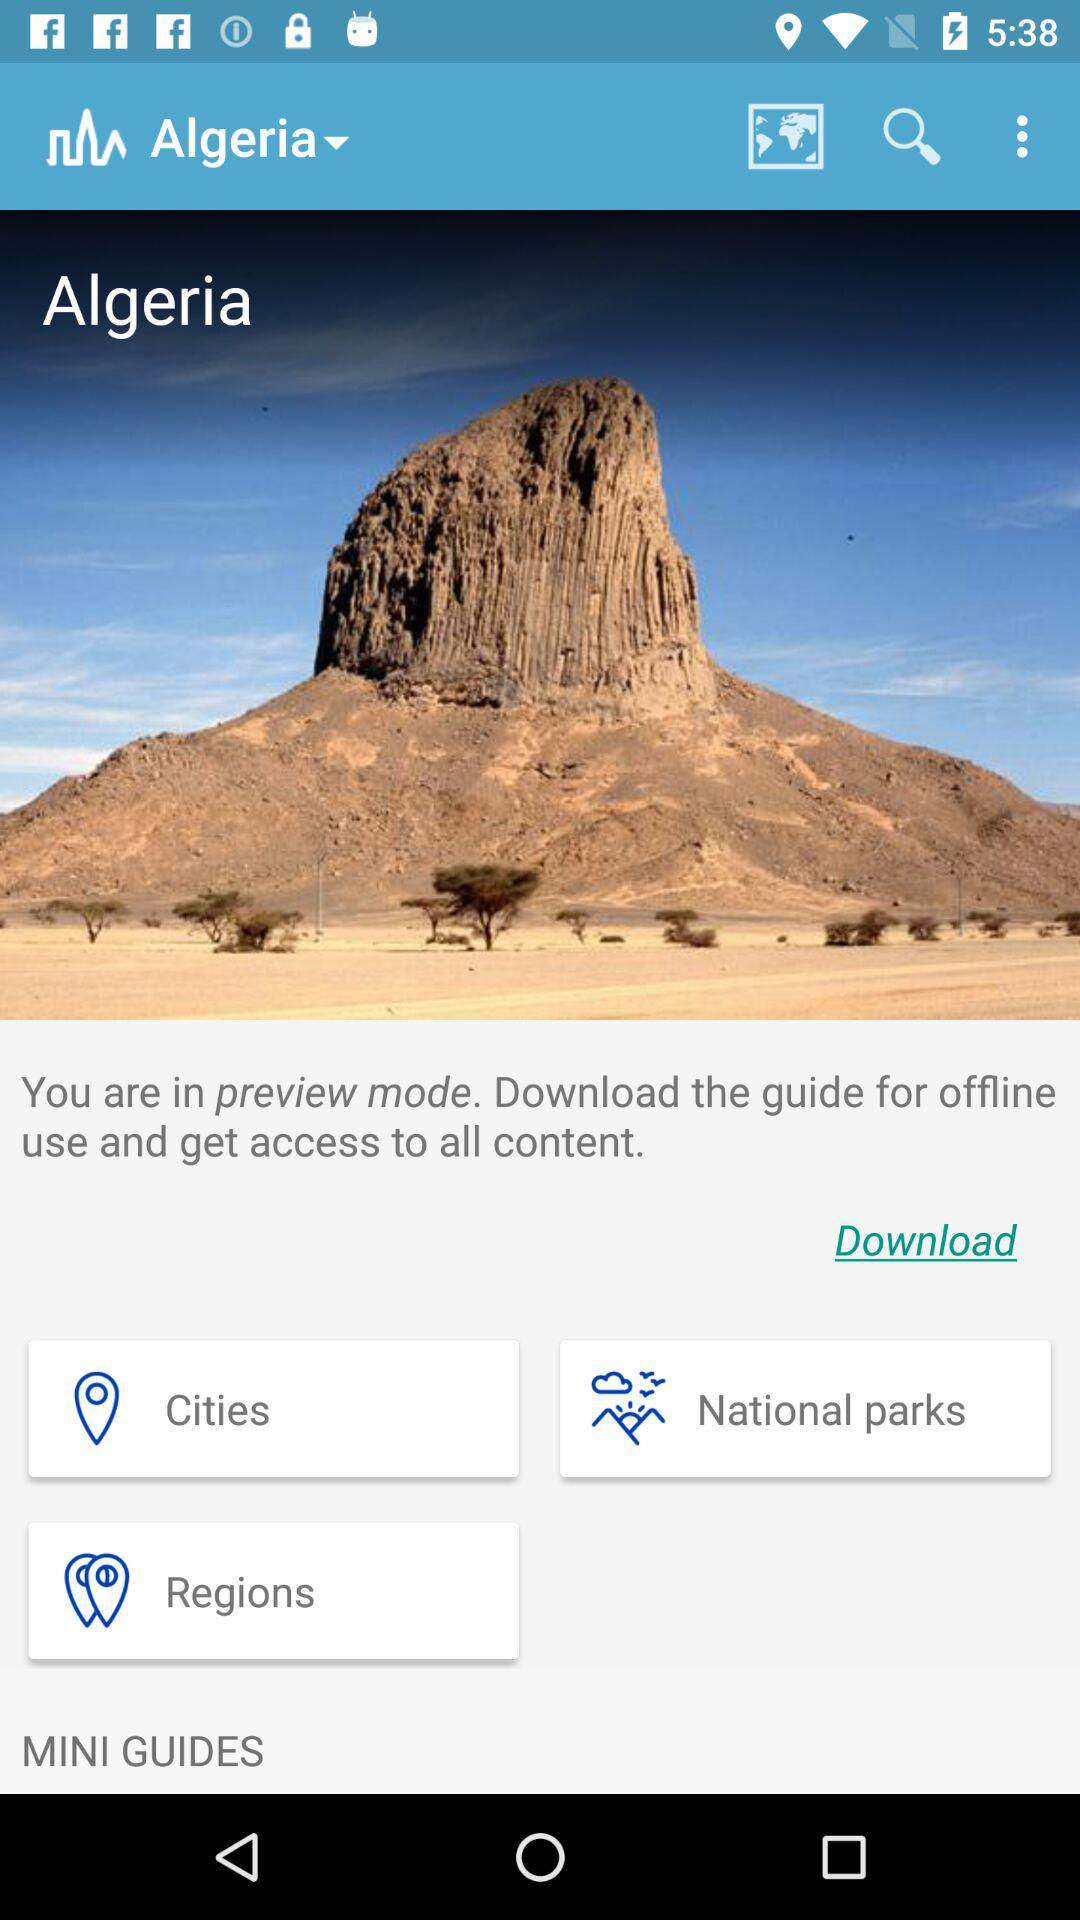How to get access to all the content? You can get access to all the content by downloading the guide for offline use. 